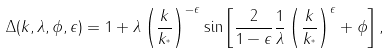<formula> <loc_0><loc_0><loc_500><loc_500>\Delta ( k , \lambda , \phi , \epsilon ) = 1 + \lambda \left ( \frac { k } { k _ { ^ { * } } } \right ) ^ { - \epsilon } \sin \left [ \frac { 2 } { 1 - \epsilon } \frac { 1 } { \lambda } \left ( \frac { k } { k _ { ^ { * } } } \right ) ^ { \epsilon } + \phi \right ] ,</formula> 